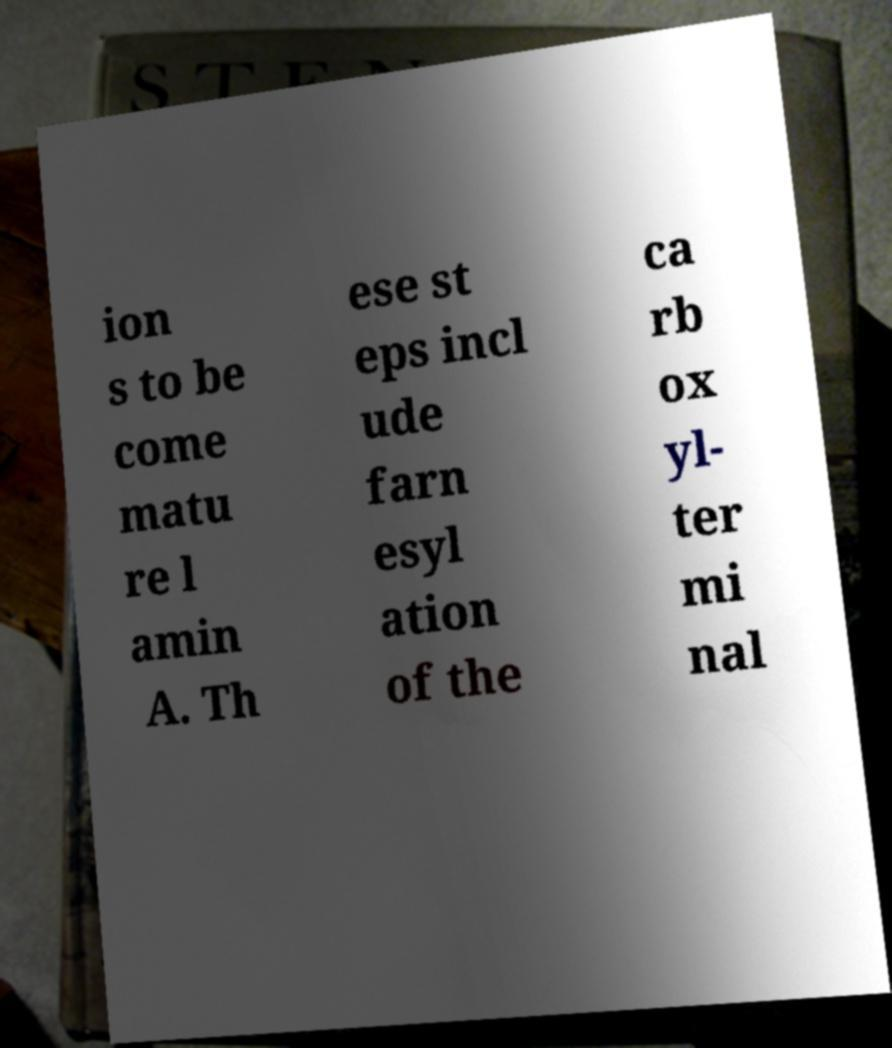I need the written content from this picture converted into text. Can you do that? ion s to be come matu re l amin A. Th ese st eps incl ude farn esyl ation of the ca rb ox yl- ter mi nal 